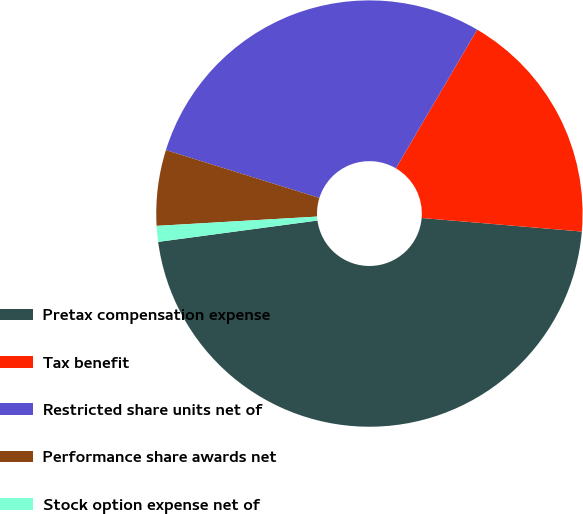<chart> <loc_0><loc_0><loc_500><loc_500><pie_chart><fcel>Pretax compensation expense<fcel>Tax benefit<fcel>Restricted share units net of<fcel>Performance share awards net<fcel>Stock option expense net of<nl><fcel>46.53%<fcel>17.91%<fcel>28.62%<fcel>5.73%<fcel>1.2%<nl></chart> 